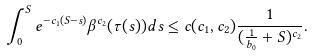<formula> <loc_0><loc_0><loc_500><loc_500>\int _ { 0 } ^ { S } e ^ { - c _ { 1 } ( S - s ) } \beta ^ { c _ { 2 } } ( \tau ( s ) ) d s \leq c ( c _ { 1 } , c _ { 2 } ) \frac { 1 } { ( \frac { 1 } { b _ { 0 } } + S ) ^ { c _ { 2 } } } .</formula> 